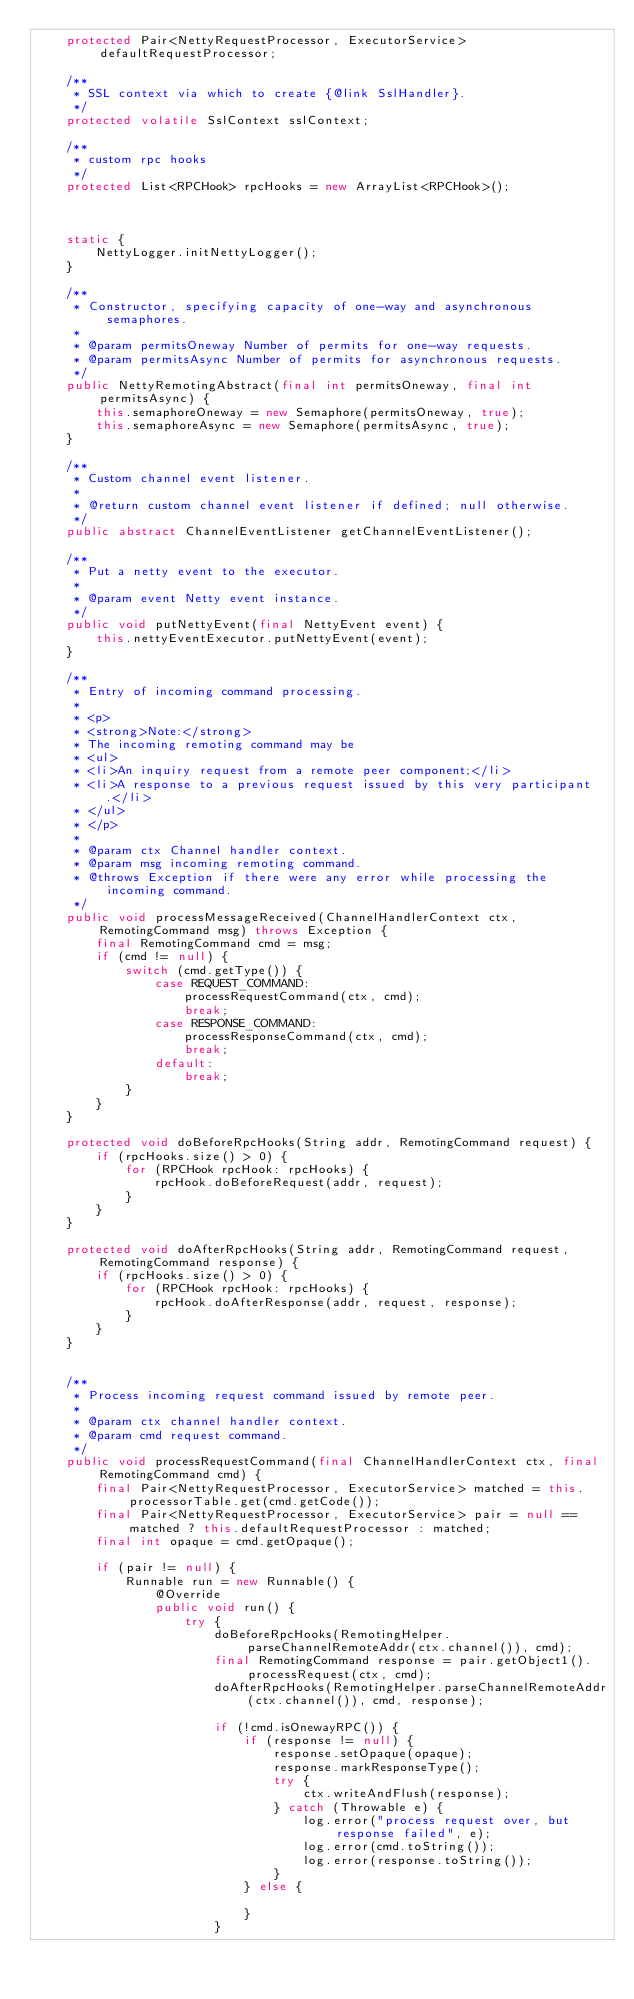<code> <loc_0><loc_0><loc_500><loc_500><_Java_>    protected Pair<NettyRequestProcessor, ExecutorService> defaultRequestProcessor;

    /**
     * SSL context via which to create {@link SslHandler}.
     */
    protected volatile SslContext sslContext;

    /**
     * custom rpc hooks
     */
    protected List<RPCHook> rpcHooks = new ArrayList<RPCHook>();



    static {
        NettyLogger.initNettyLogger();
    }

    /**
     * Constructor, specifying capacity of one-way and asynchronous semaphores.
     *
     * @param permitsOneway Number of permits for one-way requests.
     * @param permitsAsync Number of permits for asynchronous requests.
     */
    public NettyRemotingAbstract(final int permitsOneway, final int permitsAsync) {
        this.semaphoreOneway = new Semaphore(permitsOneway, true);
        this.semaphoreAsync = new Semaphore(permitsAsync, true);
    }

    /**
     * Custom channel event listener.
     *
     * @return custom channel event listener if defined; null otherwise.
     */
    public abstract ChannelEventListener getChannelEventListener();

    /**
     * Put a netty event to the executor.
     *
     * @param event Netty event instance.
     */
    public void putNettyEvent(final NettyEvent event) {
        this.nettyEventExecutor.putNettyEvent(event);
    }

    /**
     * Entry of incoming command processing.
     *
     * <p>
     * <strong>Note:</strong>
     * The incoming remoting command may be
     * <ul>
     * <li>An inquiry request from a remote peer component;</li>
     * <li>A response to a previous request issued by this very participant.</li>
     * </ul>
     * </p>
     *
     * @param ctx Channel handler context.
     * @param msg incoming remoting command.
     * @throws Exception if there were any error while processing the incoming command.
     */
    public void processMessageReceived(ChannelHandlerContext ctx, RemotingCommand msg) throws Exception {
        final RemotingCommand cmd = msg;
        if (cmd != null) {
            switch (cmd.getType()) {
                case REQUEST_COMMAND:
                    processRequestCommand(ctx, cmd);
                    break;
                case RESPONSE_COMMAND:
                    processResponseCommand(ctx, cmd);
                    break;
                default:
                    break;
            }
        }
    }

    protected void doBeforeRpcHooks(String addr, RemotingCommand request) {
        if (rpcHooks.size() > 0) {
            for (RPCHook rpcHook: rpcHooks) {
                rpcHook.doBeforeRequest(addr, request);
            }
        }
    }

    protected void doAfterRpcHooks(String addr, RemotingCommand request, RemotingCommand response) {
        if (rpcHooks.size() > 0) {
            for (RPCHook rpcHook: rpcHooks) {
                rpcHook.doAfterResponse(addr, request, response);
            }
        }
    }


    /**
     * Process incoming request command issued by remote peer.
     *
     * @param ctx channel handler context.
     * @param cmd request command.
     */
    public void processRequestCommand(final ChannelHandlerContext ctx, final RemotingCommand cmd) {
        final Pair<NettyRequestProcessor, ExecutorService> matched = this.processorTable.get(cmd.getCode());
        final Pair<NettyRequestProcessor, ExecutorService> pair = null == matched ? this.defaultRequestProcessor : matched;
        final int opaque = cmd.getOpaque();

        if (pair != null) {
            Runnable run = new Runnable() {
                @Override
                public void run() {
                    try {
                        doBeforeRpcHooks(RemotingHelper.parseChannelRemoteAddr(ctx.channel()), cmd);
                        final RemotingCommand response = pair.getObject1().processRequest(ctx, cmd);
                        doAfterRpcHooks(RemotingHelper.parseChannelRemoteAddr(ctx.channel()), cmd, response);

                        if (!cmd.isOnewayRPC()) {
                            if (response != null) {
                                response.setOpaque(opaque);
                                response.markResponseType();
                                try {
                                    ctx.writeAndFlush(response);
                                } catch (Throwable e) {
                                    log.error("process request over, but response failed", e);
                                    log.error(cmd.toString());
                                    log.error(response.toString());
                                }
                            } else {

                            }
                        }</code> 